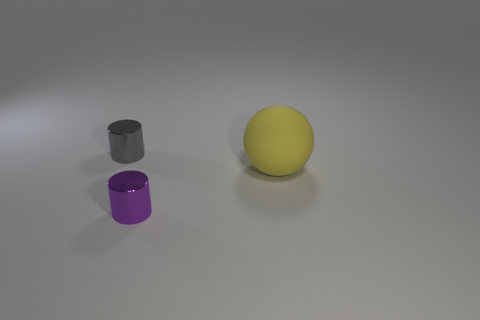What number of things are either gray cylinders or things behind the tiny purple cylinder?
Your answer should be very brief. 2. What material is the tiny gray cylinder?
Keep it short and to the point. Metal. Are there any other things of the same color as the big rubber ball?
Provide a succinct answer. No. Is the big yellow matte object the same shape as the gray metallic object?
Give a very brief answer. No. There is a rubber sphere in front of the shiny object that is on the left side of the small thing that is in front of the gray metal cylinder; how big is it?
Your answer should be very brief. Large. What number of other objects are the same material as the big yellow sphere?
Your answer should be compact. 0. What color is the small cylinder that is in front of the big yellow matte object?
Offer a very short reply. Purple. There is a small thing to the right of the object on the left side of the metal cylinder on the right side of the tiny gray shiny thing; what is it made of?
Your response must be concise. Metal. Is there another object of the same shape as the gray thing?
Your answer should be compact. Yes. What shape is the purple shiny thing that is the same size as the gray metallic cylinder?
Your answer should be compact. Cylinder. 